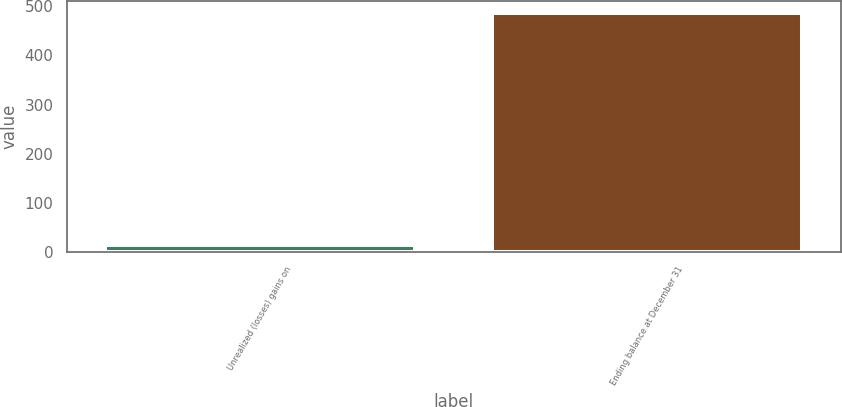Convert chart. <chart><loc_0><loc_0><loc_500><loc_500><bar_chart><fcel>Unrealized (losses) gains on<fcel>Ending balance at December 31<nl><fcel>15<fcel>486<nl></chart> 